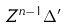Convert formula to latex. <formula><loc_0><loc_0><loc_500><loc_500>Z ^ { n - 1 } \Delta ^ { \prime }</formula> 